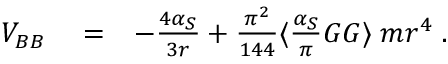Convert formula to latex. <formula><loc_0><loc_0><loc_500><loc_500>\begin{array} { r l r } { V _ { B B } } & = } & { - \frac { 4 \alpha _ { S } } { 3 r } + \frac { \pi ^ { 2 } } { 1 4 4 } \langle \frac { \alpha _ { S } } { \pi } G G \rangle \, m r ^ { 4 } \, . } \end{array}</formula> 